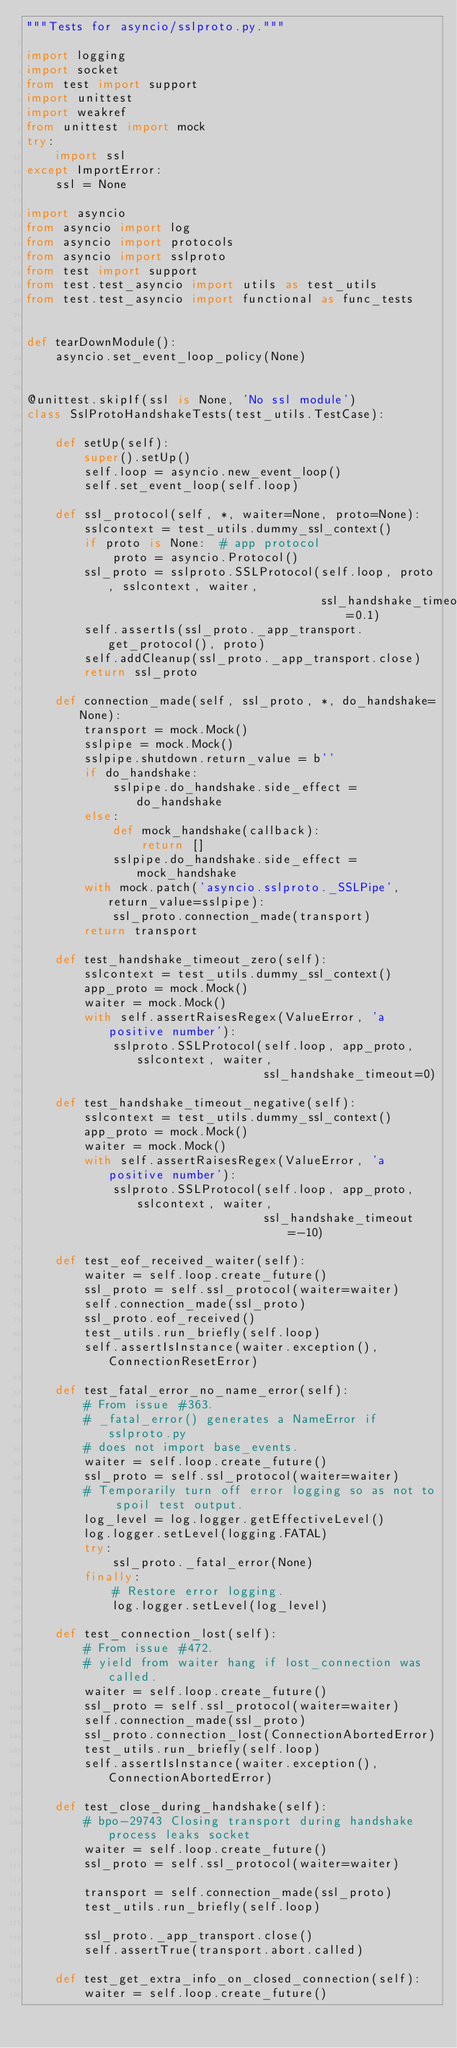Convert code to text. <code><loc_0><loc_0><loc_500><loc_500><_Python_>"""Tests for asyncio/sslproto.py."""

import logging
import socket
from test import support
import unittest
import weakref
from unittest import mock
try:
    import ssl
except ImportError:
    ssl = None

import asyncio
from asyncio import log
from asyncio import protocols
from asyncio import sslproto
from test import support
from test.test_asyncio import utils as test_utils
from test.test_asyncio import functional as func_tests


def tearDownModule():
    asyncio.set_event_loop_policy(None)


@unittest.skipIf(ssl is None, 'No ssl module')
class SslProtoHandshakeTests(test_utils.TestCase):

    def setUp(self):
        super().setUp()
        self.loop = asyncio.new_event_loop()
        self.set_event_loop(self.loop)

    def ssl_protocol(self, *, waiter=None, proto=None):
        sslcontext = test_utils.dummy_ssl_context()
        if proto is None:  # app protocol
            proto = asyncio.Protocol()
        ssl_proto = sslproto.SSLProtocol(self.loop, proto, sslcontext, waiter,
                                         ssl_handshake_timeout=0.1)
        self.assertIs(ssl_proto._app_transport.get_protocol(), proto)
        self.addCleanup(ssl_proto._app_transport.close)
        return ssl_proto

    def connection_made(self, ssl_proto, *, do_handshake=None):
        transport = mock.Mock()
        sslpipe = mock.Mock()
        sslpipe.shutdown.return_value = b''
        if do_handshake:
            sslpipe.do_handshake.side_effect = do_handshake
        else:
            def mock_handshake(callback):
                return []
            sslpipe.do_handshake.side_effect = mock_handshake
        with mock.patch('asyncio.sslproto._SSLPipe', return_value=sslpipe):
            ssl_proto.connection_made(transport)
        return transport

    def test_handshake_timeout_zero(self):
        sslcontext = test_utils.dummy_ssl_context()
        app_proto = mock.Mock()
        waiter = mock.Mock()
        with self.assertRaisesRegex(ValueError, 'a positive number'):
            sslproto.SSLProtocol(self.loop, app_proto, sslcontext, waiter,
                                 ssl_handshake_timeout=0)

    def test_handshake_timeout_negative(self):
        sslcontext = test_utils.dummy_ssl_context()
        app_proto = mock.Mock()
        waiter = mock.Mock()
        with self.assertRaisesRegex(ValueError, 'a positive number'):
            sslproto.SSLProtocol(self.loop, app_proto, sslcontext, waiter,
                                 ssl_handshake_timeout=-10)

    def test_eof_received_waiter(self):
        waiter = self.loop.create_future()
        ssl_proto = self.ssl_protocol(waiter=waiter)
        self.connection_made(ssl_proto)
        ssl_proto.eof_received()
        test_utils.run_briefly(self.loop)
        self.assertIsInstance(waiter.exception(), ConnectionResetError)

    def test_fatal_error_no_name_error(self):
        # From issue #363.
        # _fatal_error() generates a NameError if sslproto.py
        # does not import base_events.
        waiter = self.loop.create_future()
        ssl_proto = self.ssl_protocol(waiter=waiter)
        # Temporarily turn off error logging so as not to spoil test output.
        log_level = log.logger.getEffectiveLevel()
        log.logger.setLevel(logging.FATAL)
        try:
            ssl_proto._fatal_error(None)
        finally:
            # Restore error logging.
            log.logger.setLevel(log_level)

    def test_connection_lost(self):
        # From issue #472.
        # yield from waiter hang if lost_connection was called.
        waiter = self.loop.create_future()
        ssl_proto = self.ssl_protocol(waiter=waiter)
        self.connection_made(ssl_proto)
        ssl_proto.connection_lost(ConnectionAbortedError)
        test_utils.run_briefly(self.loop)
        self.assertIsInstance(waiter.exception(), ConnectionAbortedError)

    def test_close_during_handshake(self):
        # bpo-29743 Closing transport during handshake process leaks socket
        waiter = self.loop.create_future()
        ssl_proto = self.ssl_protocol(waiter=waiter)

        transport = self.connection_made(ssl_proto)
        test_utils.run_briefly(self.loop)

        ssl_proto._app_transport.close()
        self.assertTrue(transport.abort.called)

    def test_get_extra_info_on_closed_connection(self):
        waiter = self.loop.create_future()</code> 